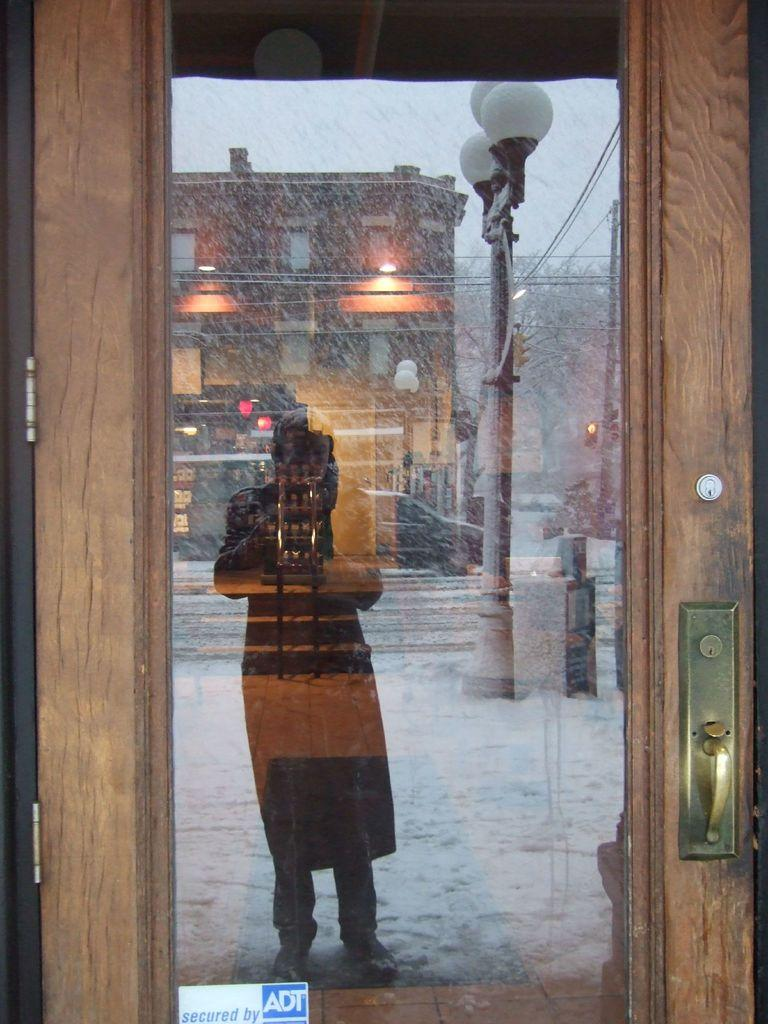What type of door is present in the image? There is a glass door in the image. What can be seen on the glass door due to its reflective surface? A person's reflection, a car's reflection, a pole's reflection, lights' reflection, a building's reflection, a tree's reflection, and the sky's reflection are visible on the glass door. Can you see a plane flying in the sky's reflection on the glass door? There is no plane visible in the sky's reflection on the glass door in the image. 